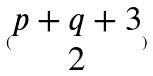Convert formula to latex. <formula><loc_0><loc_0><loc_500><loc_500>( \begin{matrix} p + q + 3 \\ 2 \end{matrix} )</formula> 